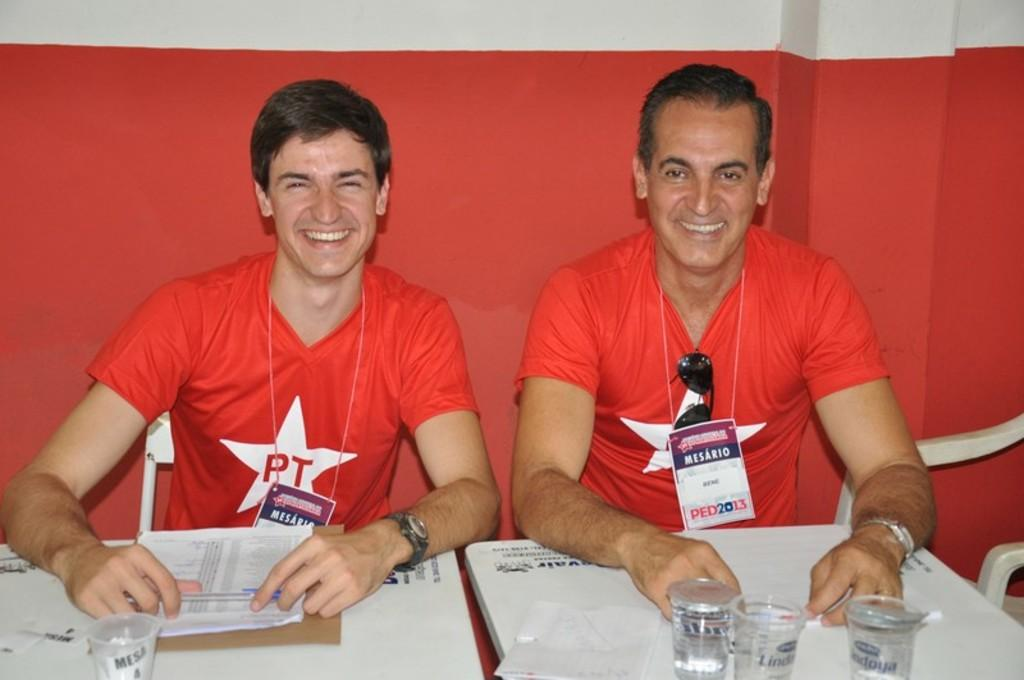Provide a one-sentence caption for the provided image. Two white males sitting next to each other in read shirts with PT in a star on them. 